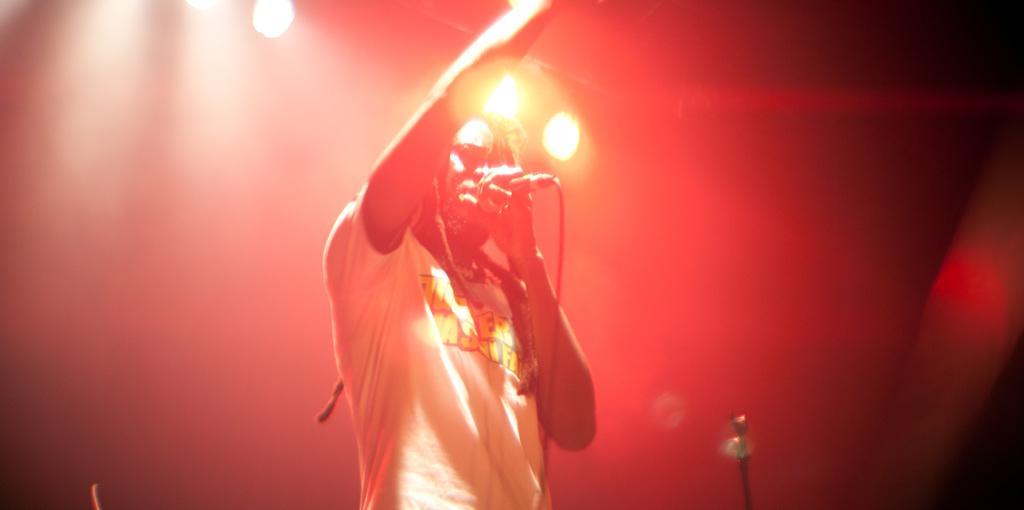Can you describe this image briefly? In this picture there is an African man wearing white color t-shirt is singing on the microphone. Behind there is a red color background and spotlights. 